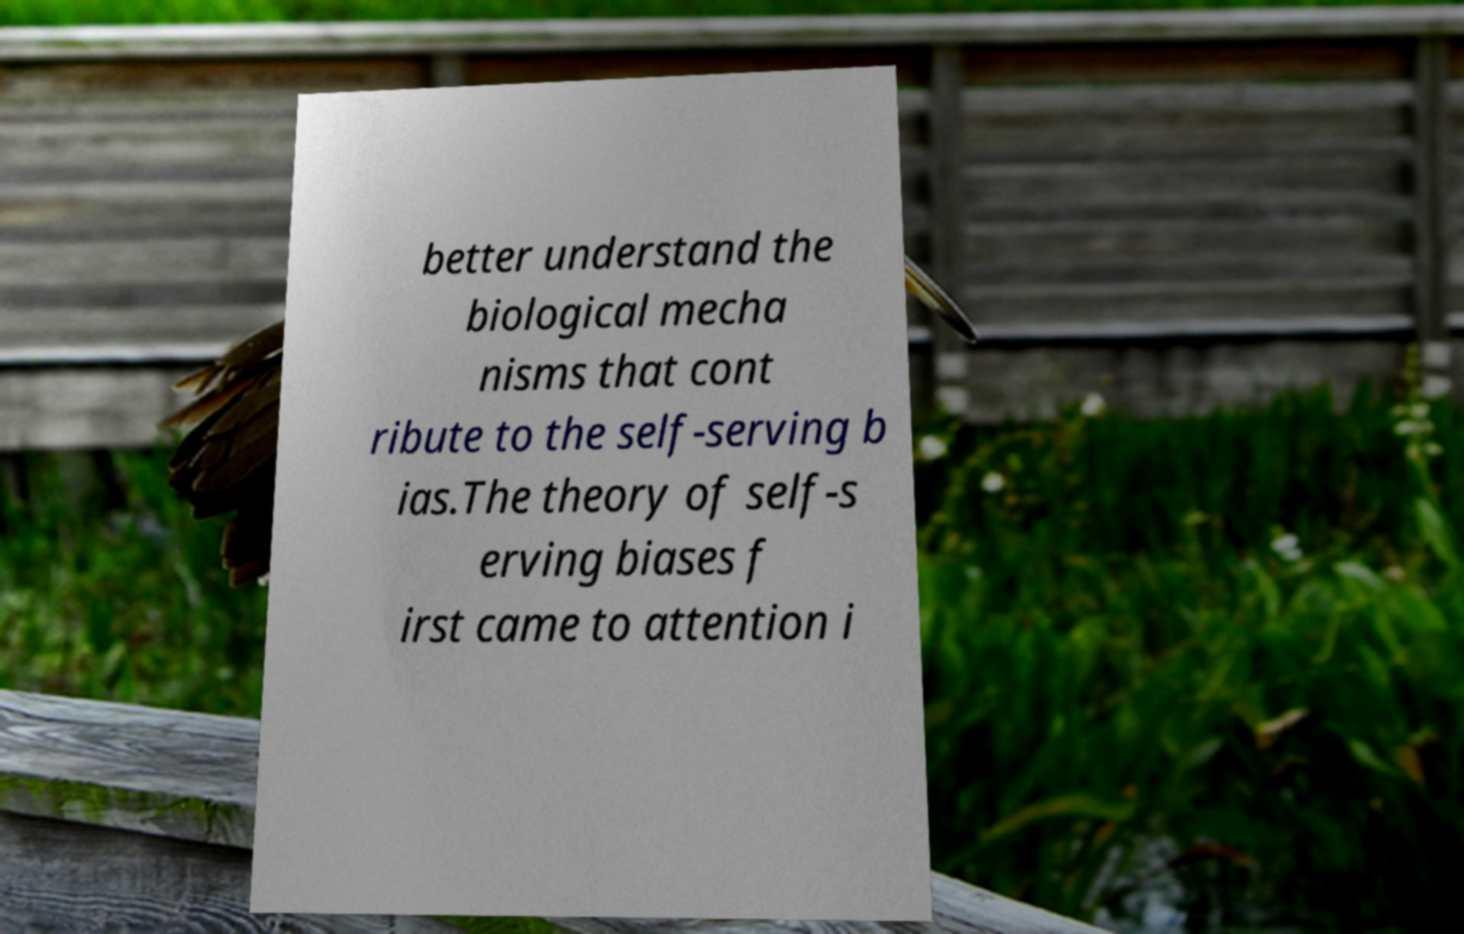There's text embedded in this image that I need extracted. Can you transcribe it verbatim? better understand the biological mecha nisms that cont ribute to the self-serving b ias.The theory of self-s erving biases f irst came to attention i 